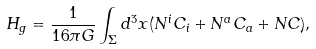<formula> <loc_0><loc_0><loc_500><loc_500>H _ { g } = \frac { 1 } { 1 6 \pi G } \int _ { \Sigma } d ^ { 3 } { x } ( N ^ { i } C _ { i } + N ^ { a } C _ { a } + N C ) ,</formula> 